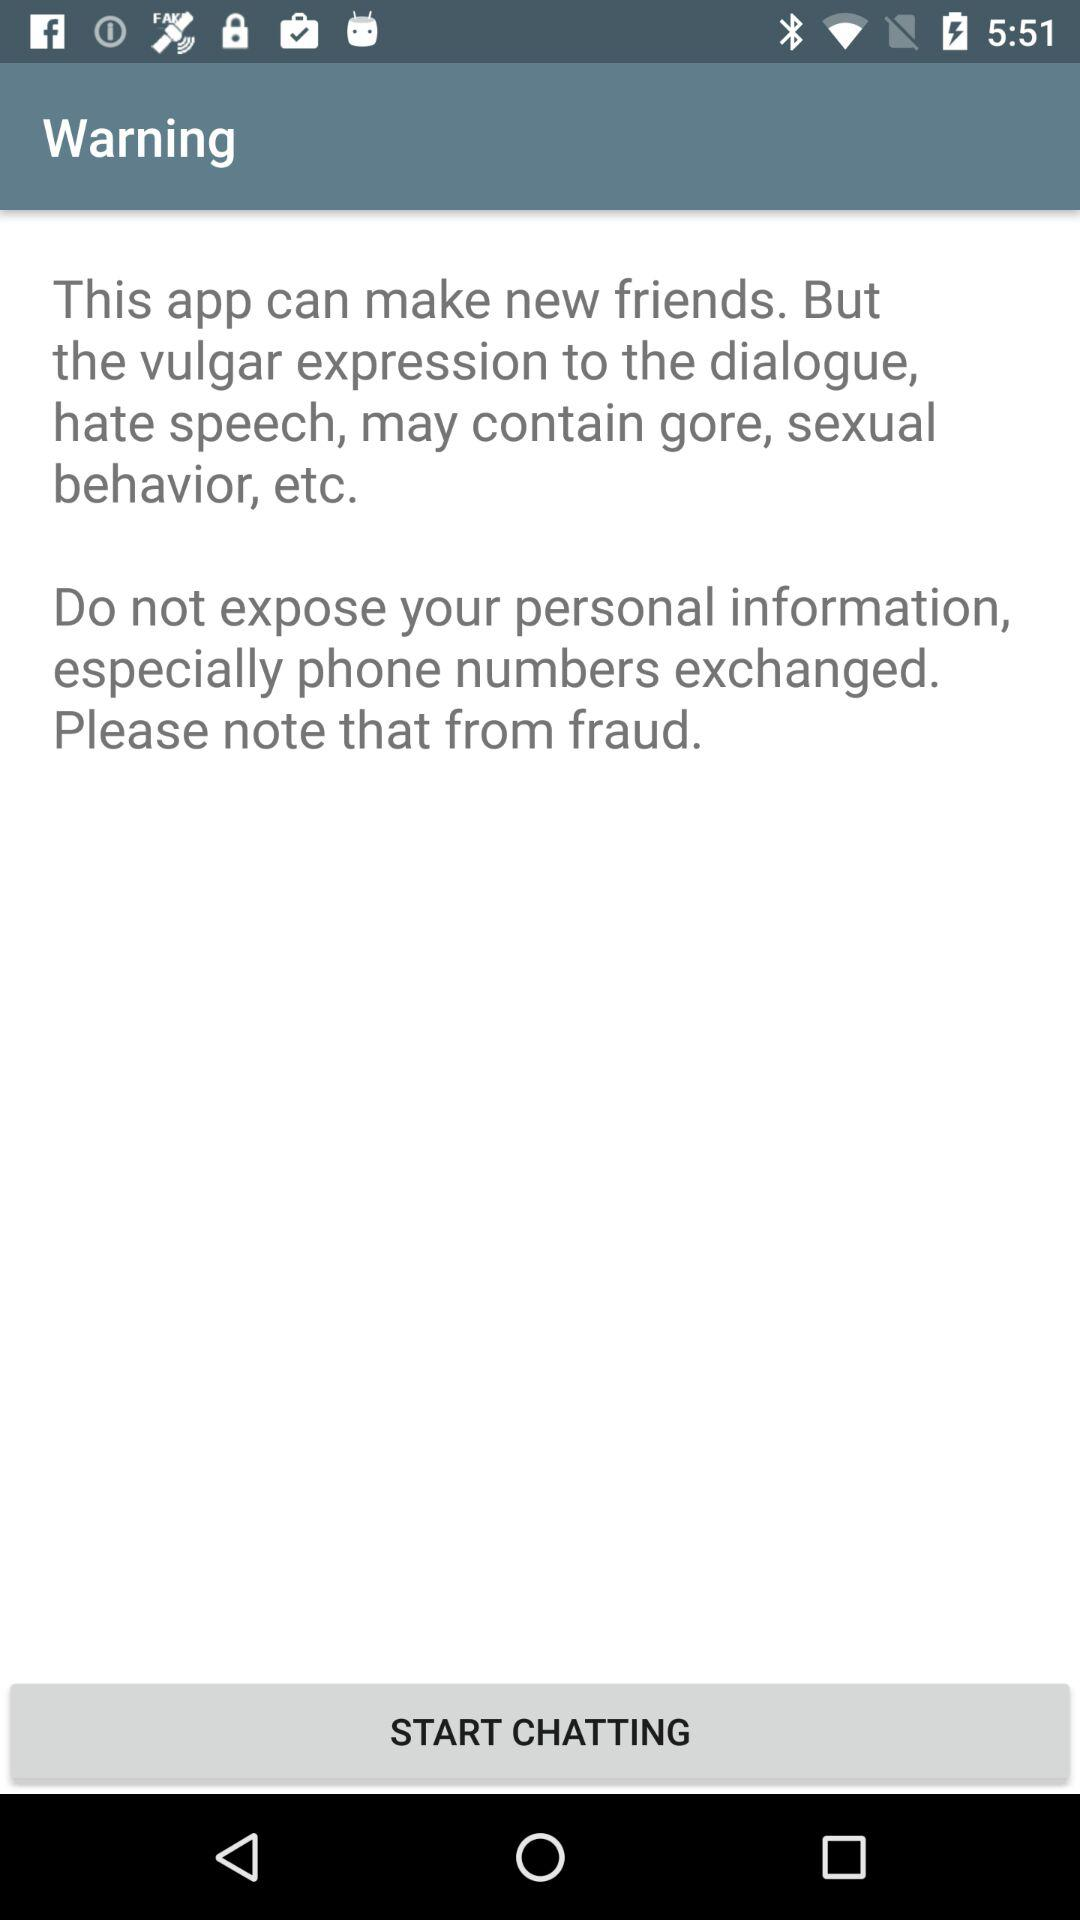What personal information is not allowed to be exposed? You are not allowed to expose phone number. 